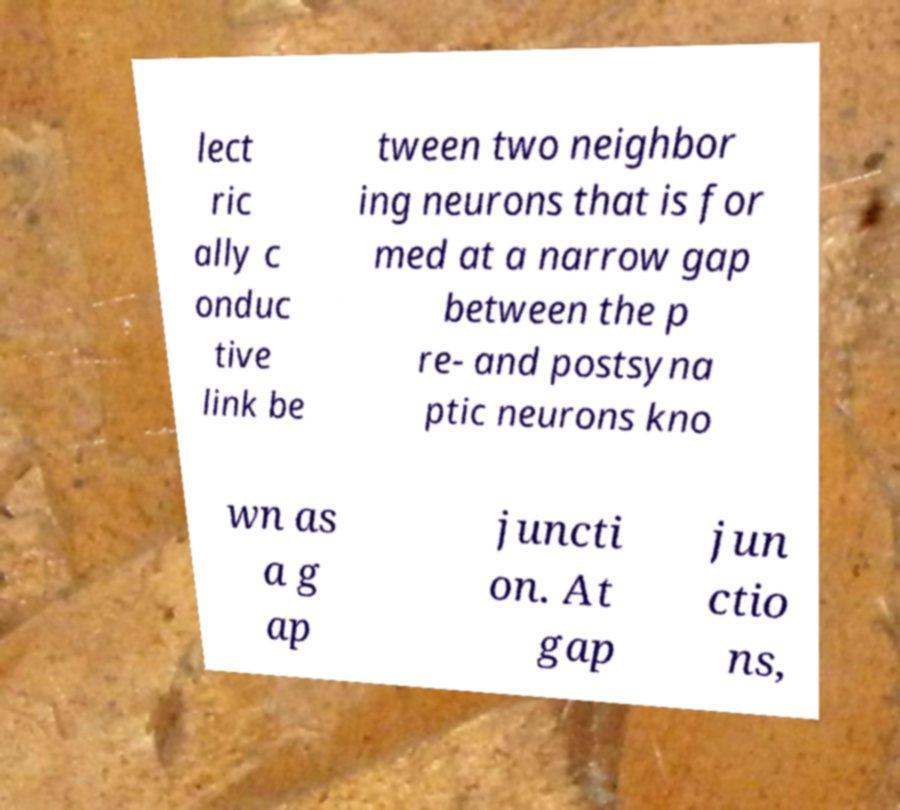I need the written content from this picture converted into text. Can you do that? lect ric ally c onduc tive link be tween two neighbor ing neurons that is for med at a narrow gap between the p re- and postsyna ptic neurons kno wn as a g ap juncti on. At gap jun ctio ns, 